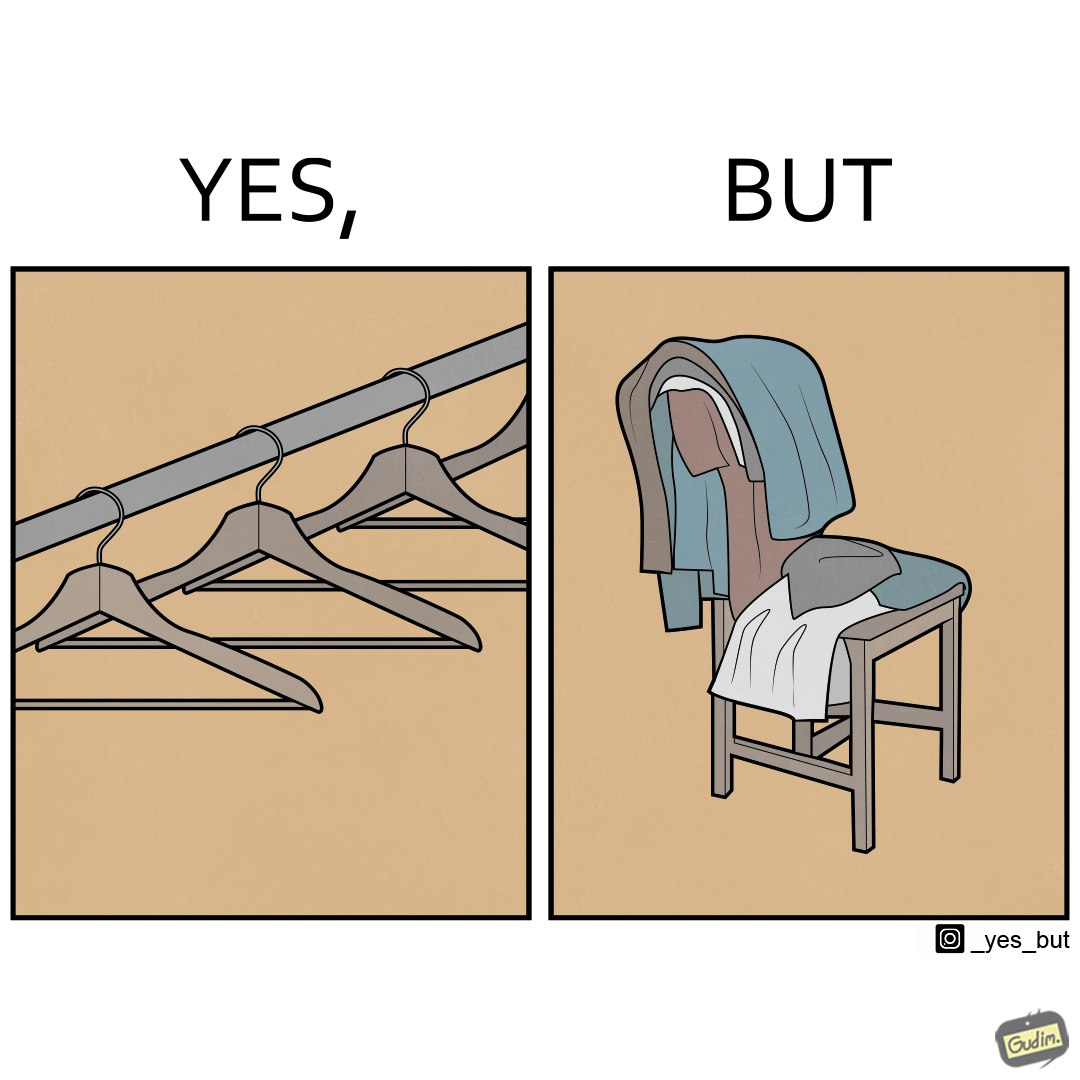Describe the satirical element in this image. the image highlights irony when people make expensive and fancy wardrobes just to end up stacking all the clothes on a chair 